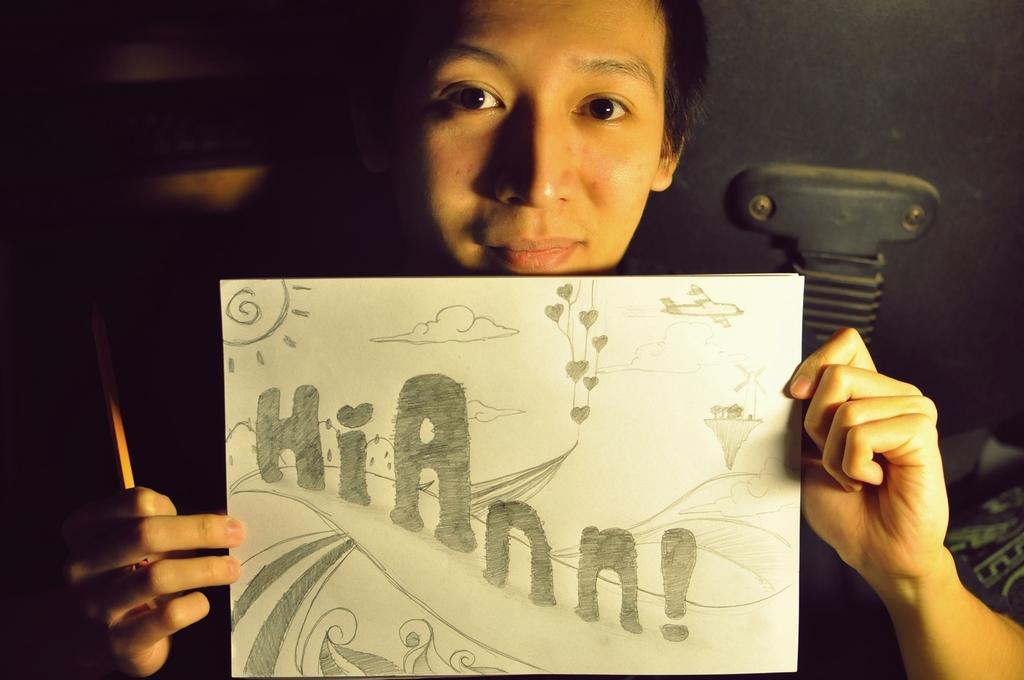Please provide a concise description of this image. In this picture, we can see a person holding a pencil, paper and some designed text and art on it, and we can see some objects on the right side of the picture, and we can see the dark background, 